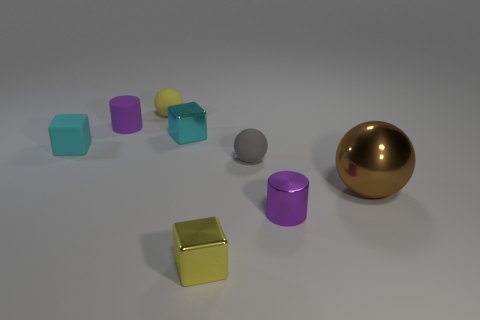Subtract all matte cubes. How many cubes are left? 2 Subtract all balls. How many objects are left? 5 Subtract all yellow balls. How many balls are left? 2 Subtract all gray cylinders. How many brown spheres are left? 1 Subtract all tiny blue metal objects. Subtract all cyan things. How many objects are left? 6 Add 1 small cyan cubes. How many small cyan cubes are left? 3 Add 4 large blocks. How many large blocks exist? 4 Add 2 tiny red rubber cubes. How many objects exist? 10 Subtract 2 purple cylinders. How many objects are left? 6 Subtract 2 cubes. How many cubes are left? 1 